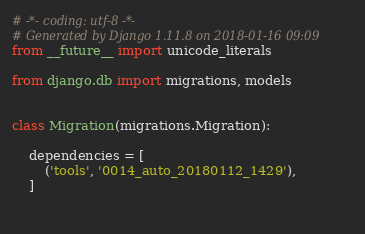Convert code to text. <code><loc_0><loc_0><loc_500><loc_500><_Python_># -*- coding: utf-8 -*-
# Generated by Django 1.11.8 on 2018-01-16 09:09
from __future__ import unicode_literals

from django.db import migrations, models


class Migration(migrations.Migration):

    dependencies = [
        ('tools', '0014_auto_20180112_1429'),
    ]

    </code> 